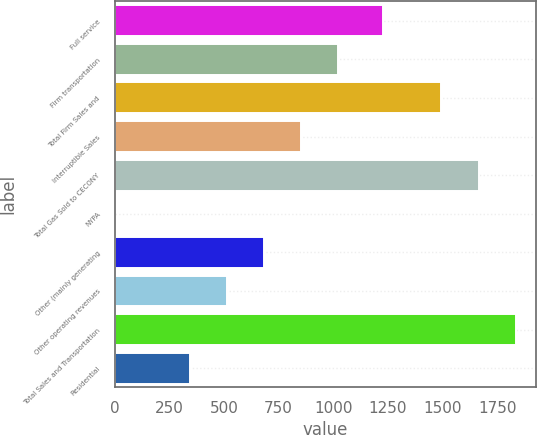Convert chart to OTSL. <chart><loc_0><loc_0><loc_500><loc_500><bar_chart><fcel>Full service<fcel>Firm transportation<fcel>Total Firm Sales and<fcel>Interruptible Sales<fcel>Total Gas Sold to CECONY<fcel>NYPA<fcel>Other (mainly generating<fcel>Other operating revenues<fcel>Total Sales and Transportation<fcel>Residential<nl><fcel>1229<fcel>1022.2<fcel>1495<fcel>852.5<fcel>1664.7<fcel>4<fcel>682.8<fcel>513.1<fcel>1834.4<fcel>343.4<nl></chart> 